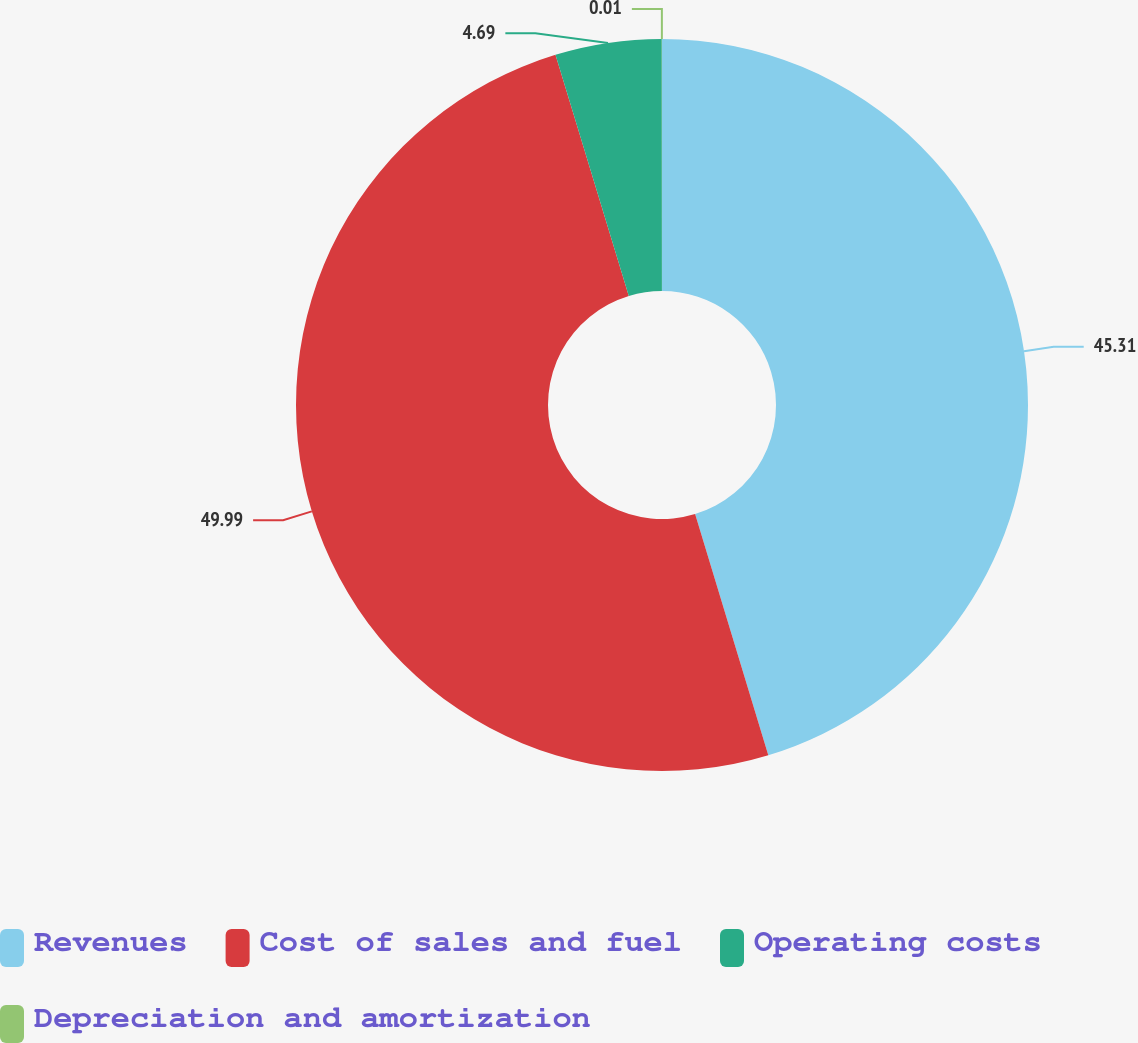<chart> <loc_0><loc_0><loc_500><loc_500><pie_chart><fcel>Revenues<fcel>Cost of sales and fuel<fcel>Operating costs<fcel>Depreciation and amortization<nl><fcel>45.31%<fcel>49.99%<fcel>4.69%<fcel>0.01%<nl></chart> 